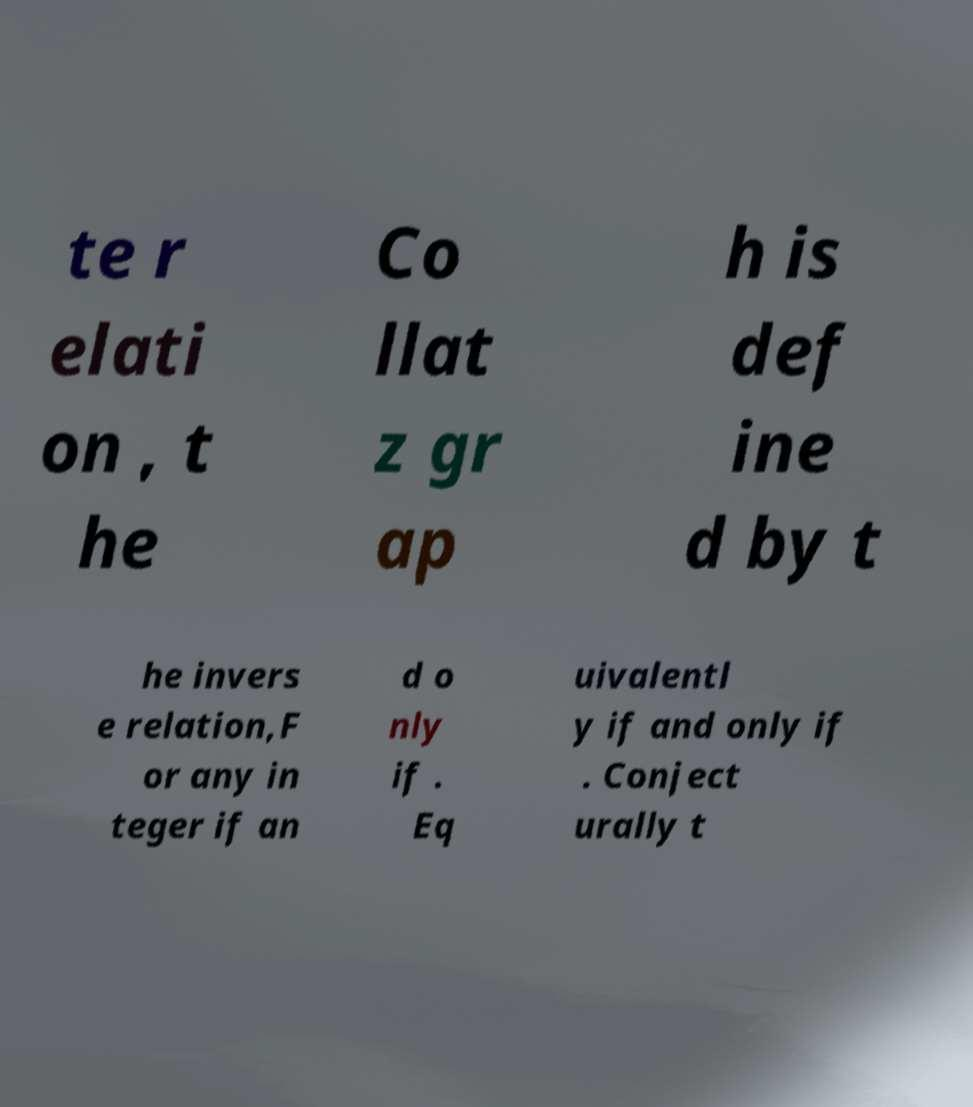For documentation purposes, I need the text within this image transcribed. Could you provide that? te r elati on , t he Co llat z gr ap h is def ine d by t he invers e relation,F or any in teger if an d o nly if . Eq uivalentl y if and only if . Conject urally t 